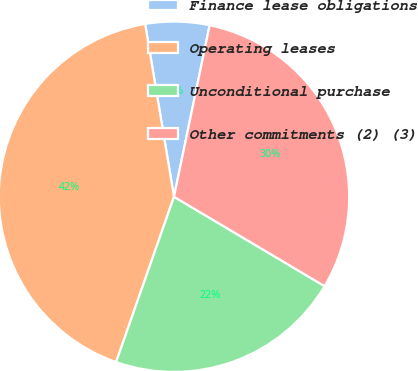Convert chart. <chart><loc_0><loc_0><loc_500><loc_500><pie_chart><fcel>Finance lease obligations<fcel>Operating leases<fcel>Unconditional purchase<fcel>Other commitments (2) (3)<nl><fcel>5.9%<fcel>42.0%<fcel>21.83%<fcel>30.26%<nl></chart> 